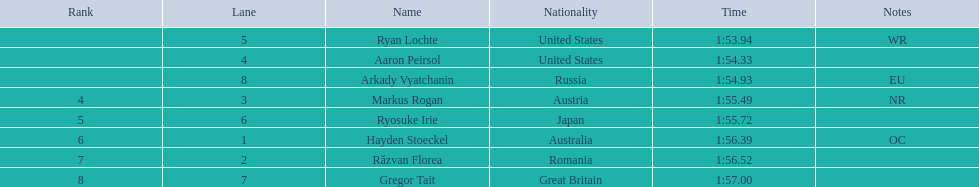What is the appellation of the contender in lane 6? Ryosuke Irie. How long did it take that sportsman to accomplish the race? 1:55.72. 